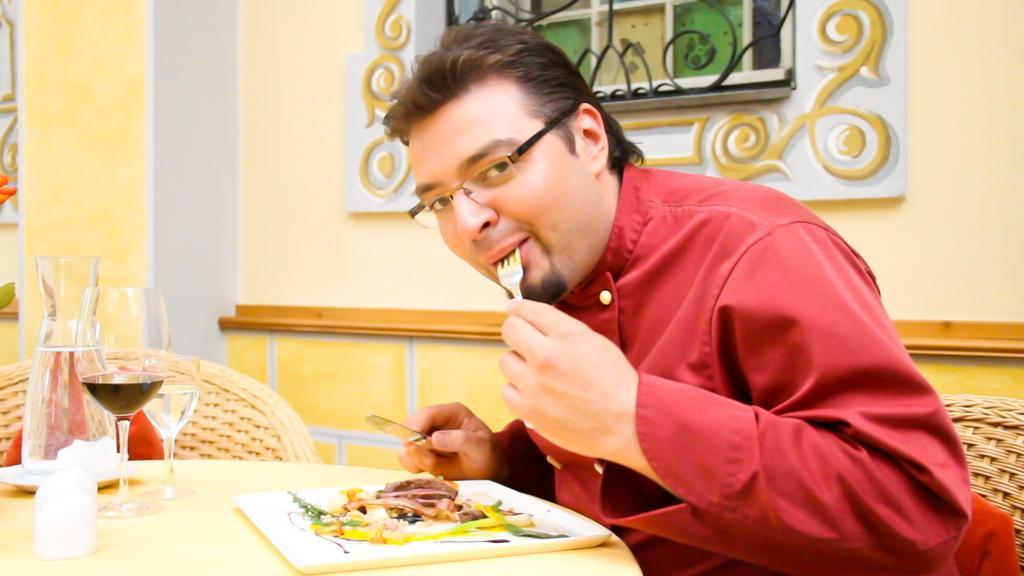Could you give a brief overview of what you see in this image? The image is inside the room. In the image there is a man who is sitting on chair holding a fork and keeping in his mouth on another hand he is holding a knife and keeping his hand on table. On table we can see a tray with some food,glass,jar,plate. In background there is a wall,window. 